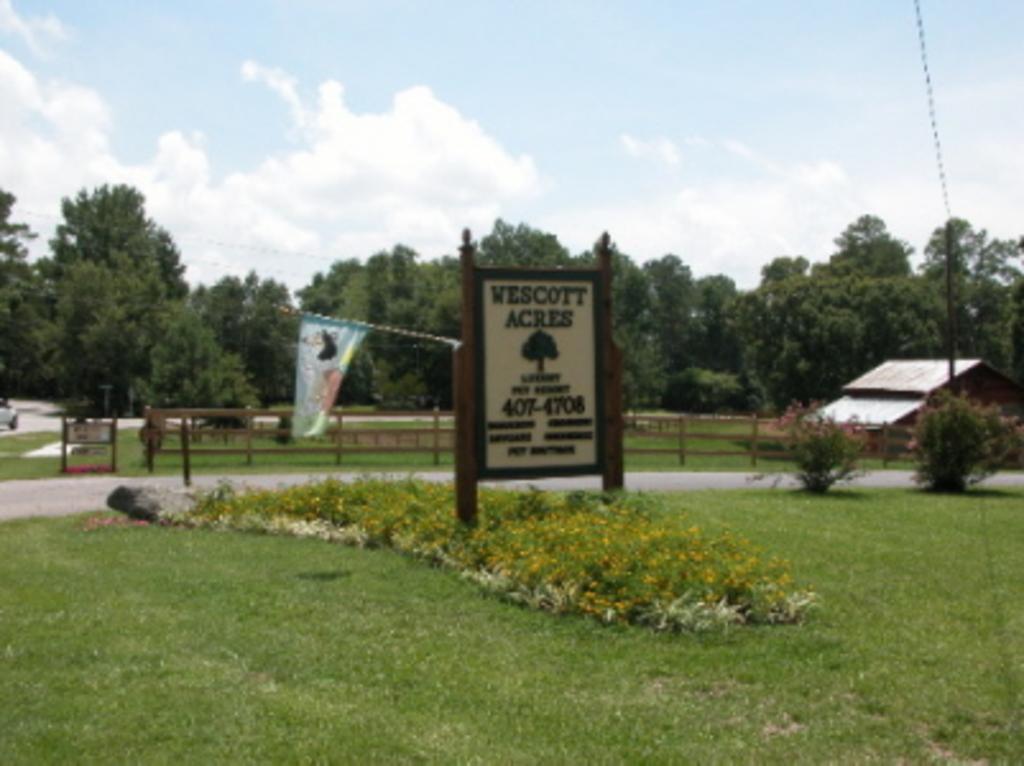Describe this image in one or two sentences. In this image I can see grass, board and a flag. There is fence behind it and there is a shed on the left. There are trees at the back. 